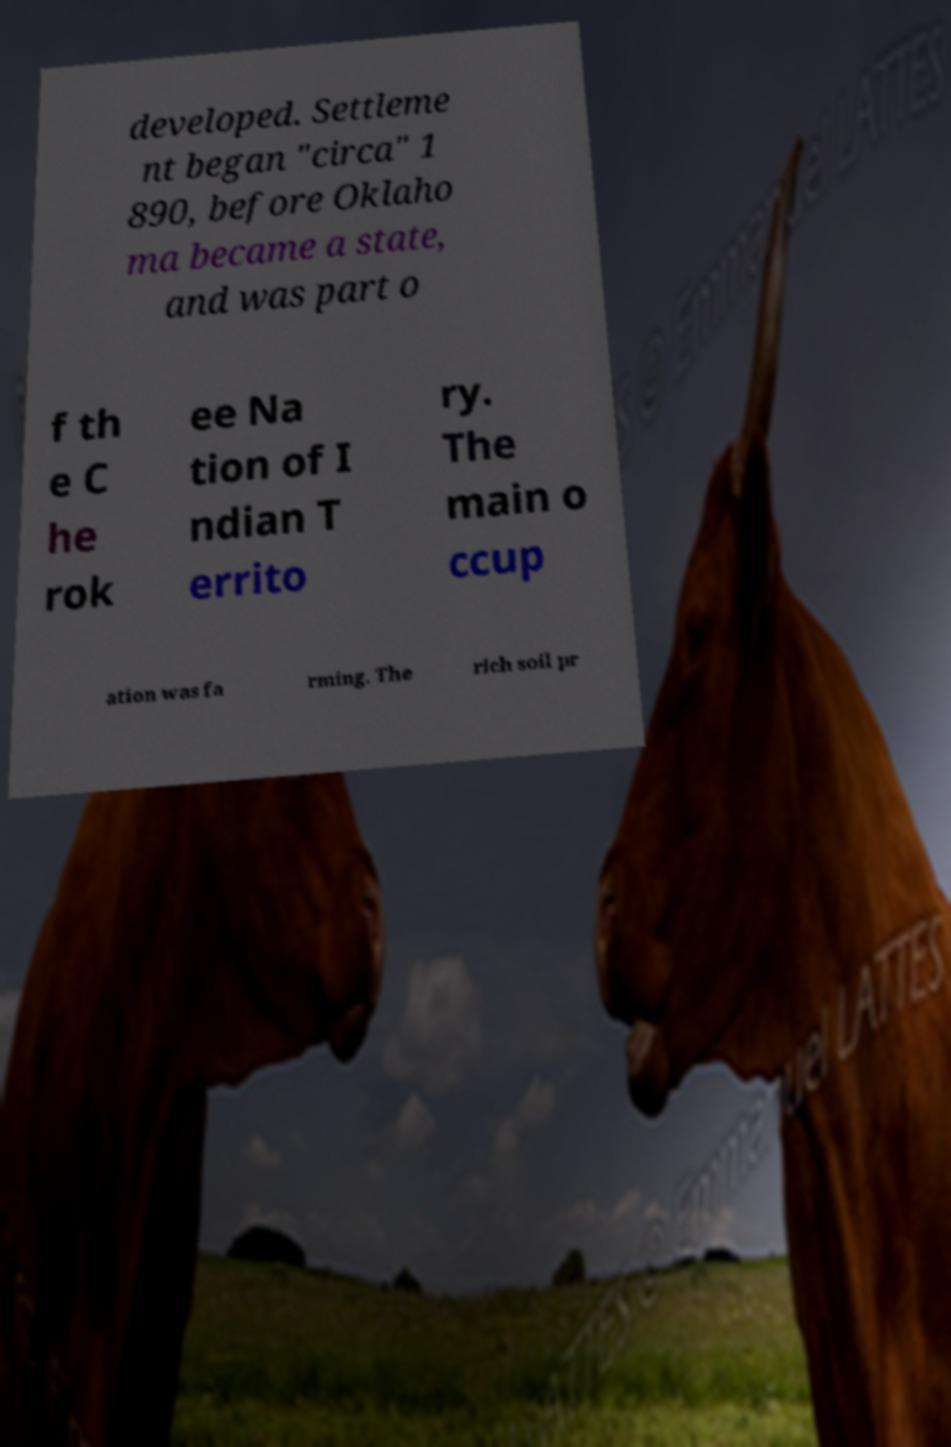What messages or text are displayed in this image? I need them in a readable, typed format. developed. Settleme nt began "circa" 1 890, before Oklaho ma became a state, and was part o f th e C he rok ee Na tion of I ndian T errito ry. The main o ccup ation was fa rming. The rich soil pr 